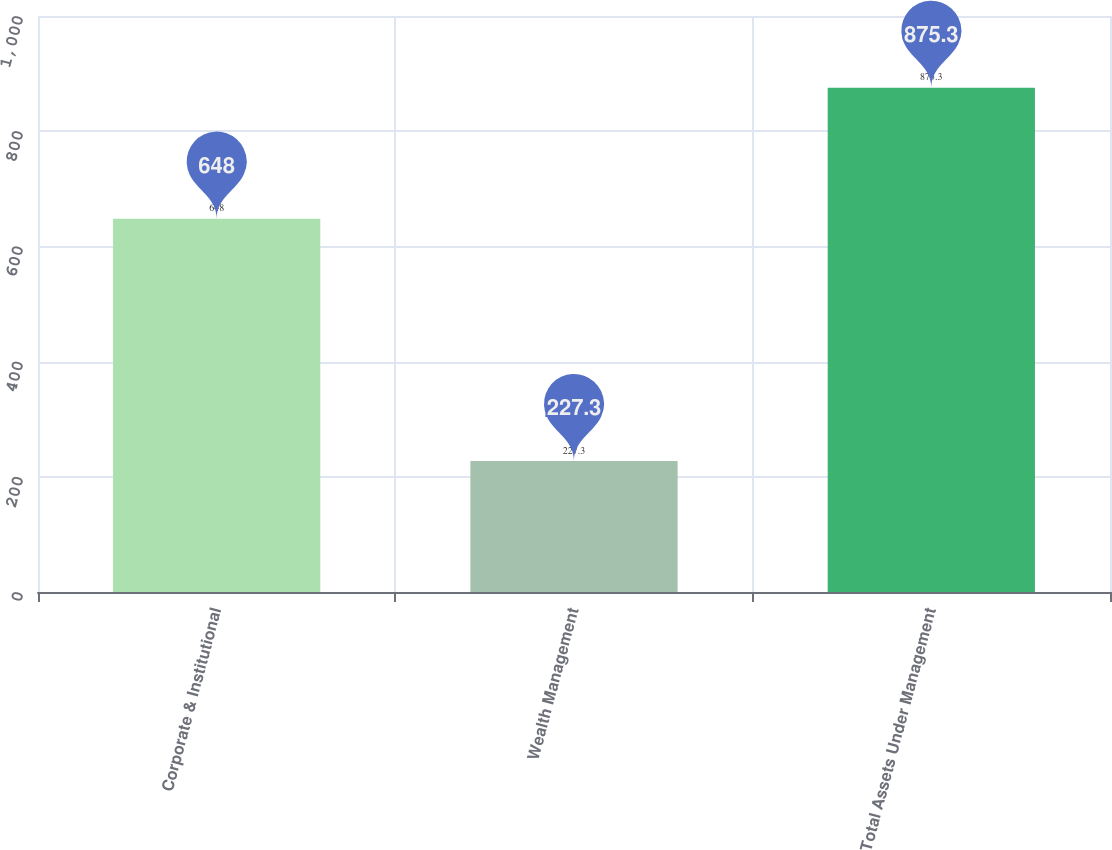<chart> <loc_0><loc_0><loc_500><loc_500><bar_chart><fcel>Corporate & Institutional<fcel>Wealth Management<fcel>Total Assets Under Management<nl><fcel>648<fcel>227.3<fcel>875.3<nl></chart> 